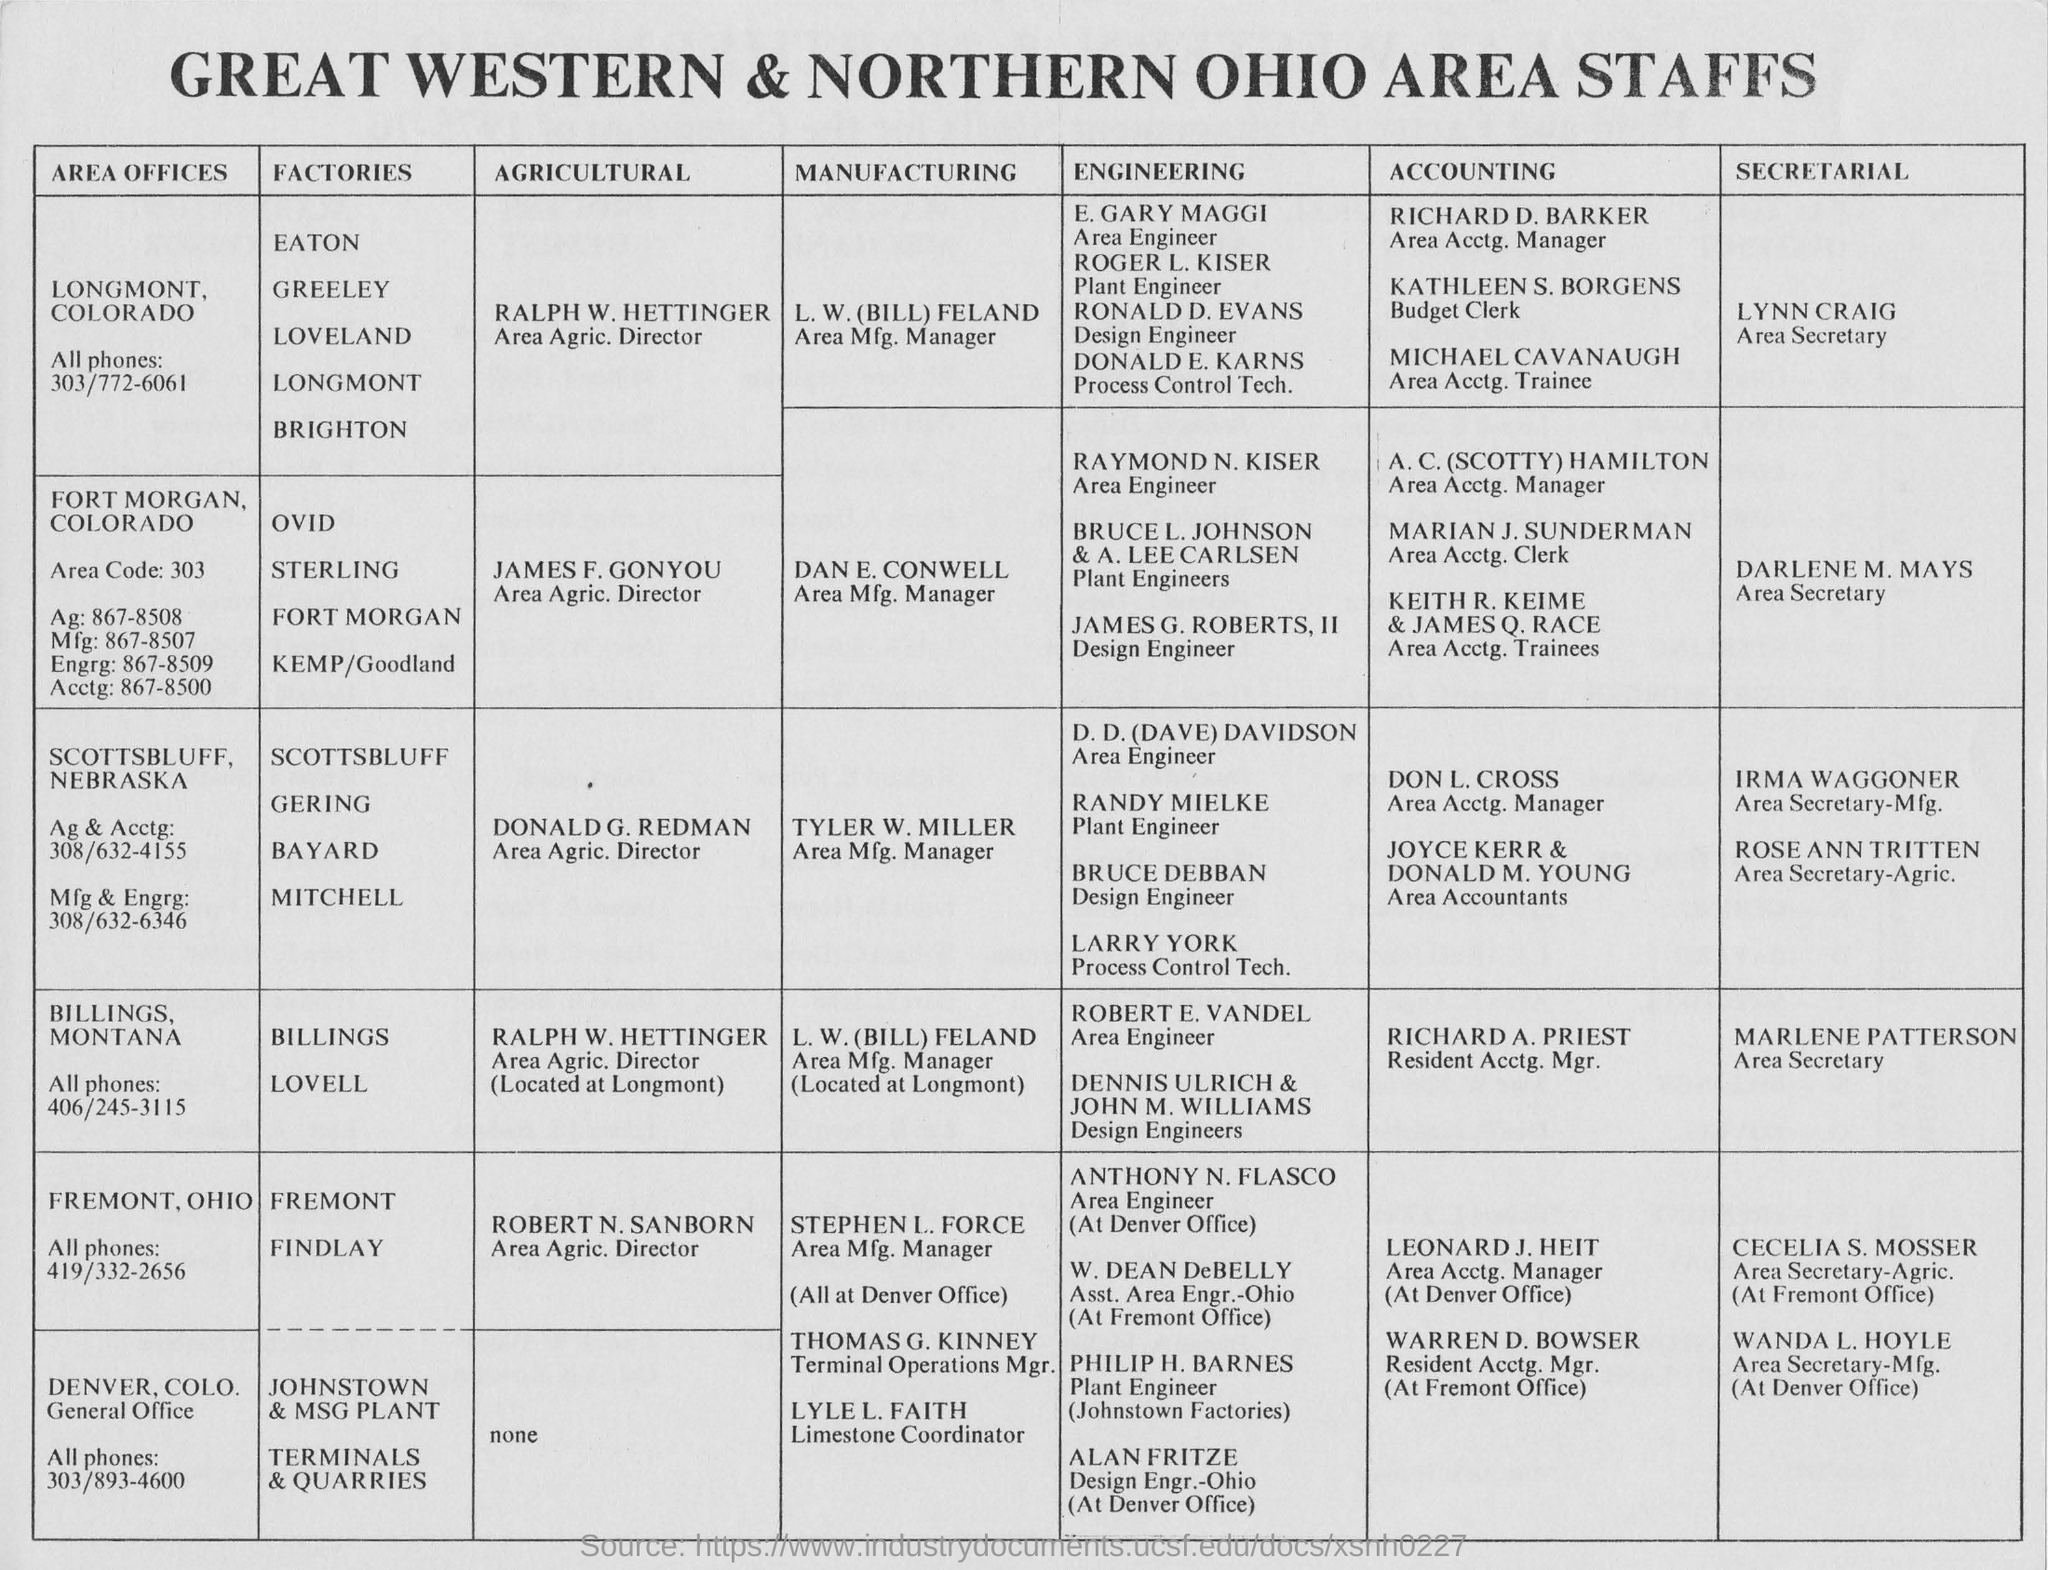Highlight a few significant elements in this photo. Lynn Craig is the Area Secretary for Longmont, Colorado. The document contains information about the people who work in the Great Western and Northern Ohio areas. Robert N Sanborn is the Agricultural Director for Fremont, Ohio. 